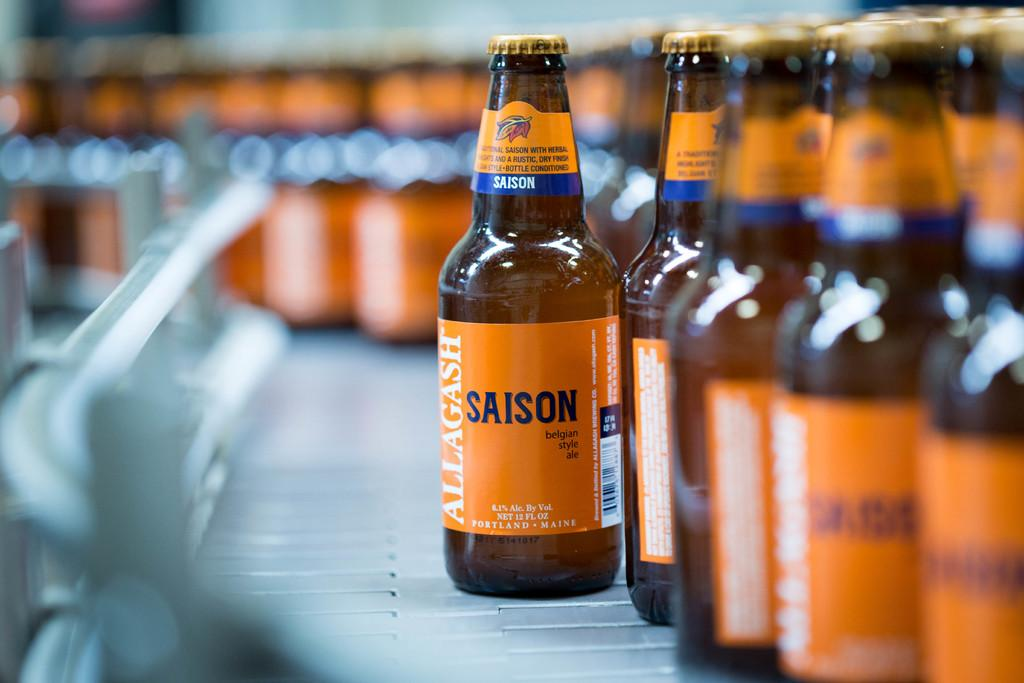<image>
Share a concise interpretation of the image provided. the word Saison is on an orange bottle 